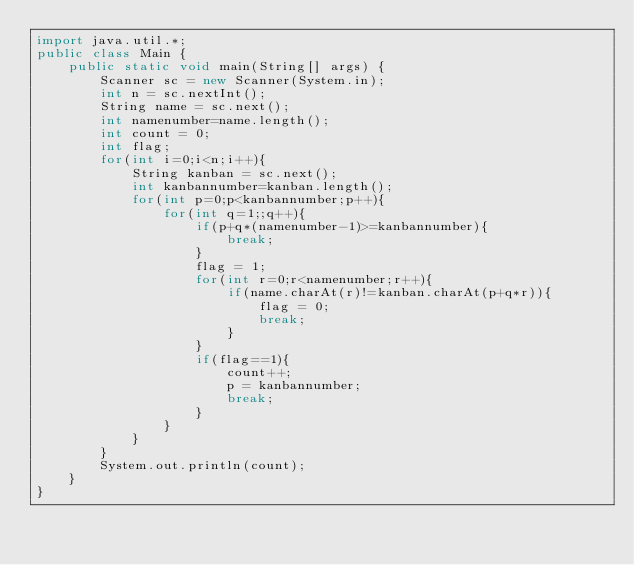Convert code to text. <code><loc_0><loc_0><loc_500><loc_500><_Java_>import java.util.*;
public class Main {
	public static void main(String[] args) {
		Scanner sc = new Scanner(System.in);
		int n = sc.nextInt();
		String name = sc.next();
		int namenumber=name.length();
		int count = 0;
		int flag;
		for(int i=0;i<n;i++){
			String kanban = sc.next();
			int kanbannumber=kanban.length();
			for(int p=0;p<kanbannumber;p++){
				for(int q=1;;q++){
					if(p+q*(namenumber-1)>=kanbannumber){
						break;
					}
					flag = 1;
					for(int r=0;r<namenumber;r++){
						if(name.charAt(r)!=kanban.charAt(p+q*r)){
							flag = 0;
							break;
						}
					}
		  			if(flag==1){
					    count++;
					    p = kanbannumber;
					    break;
					}
				}
			}
		}
		System.out.println(count);
	}	
}</code> 